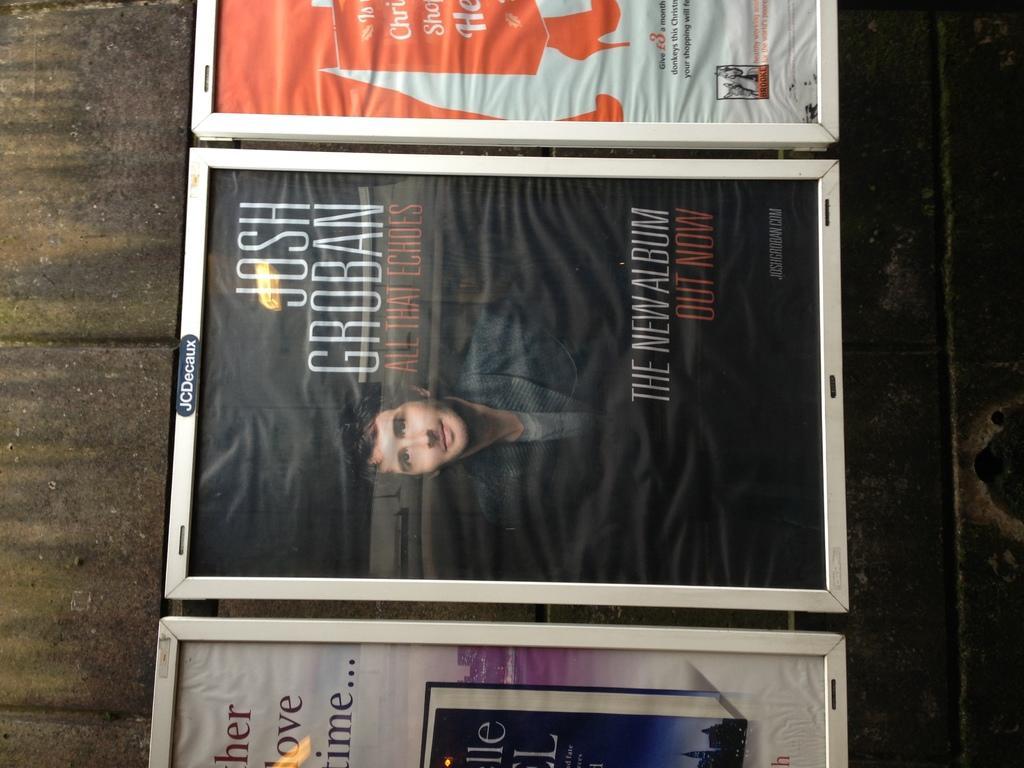How would you summarize this image in a sentence or two? In this image I can see photo frames on a wooden surface. On this photos I can see a person and something written on it. 